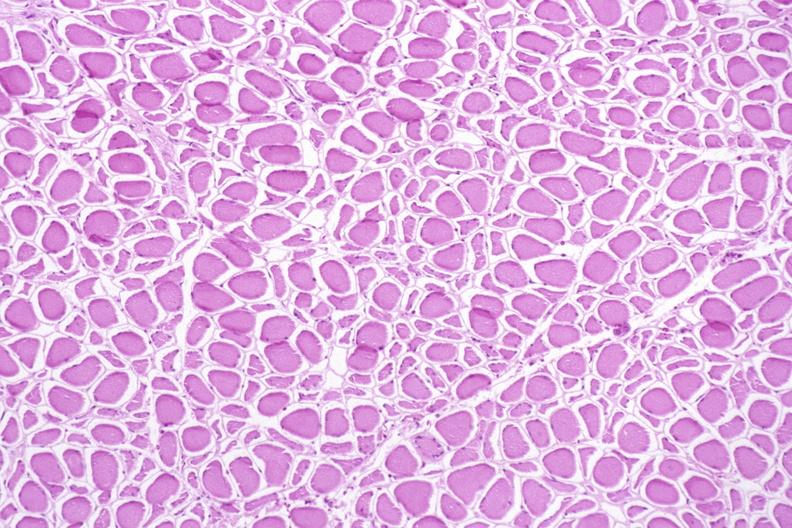s vasculitis foreign body present?
Answer the question using a single word or phrase. No 